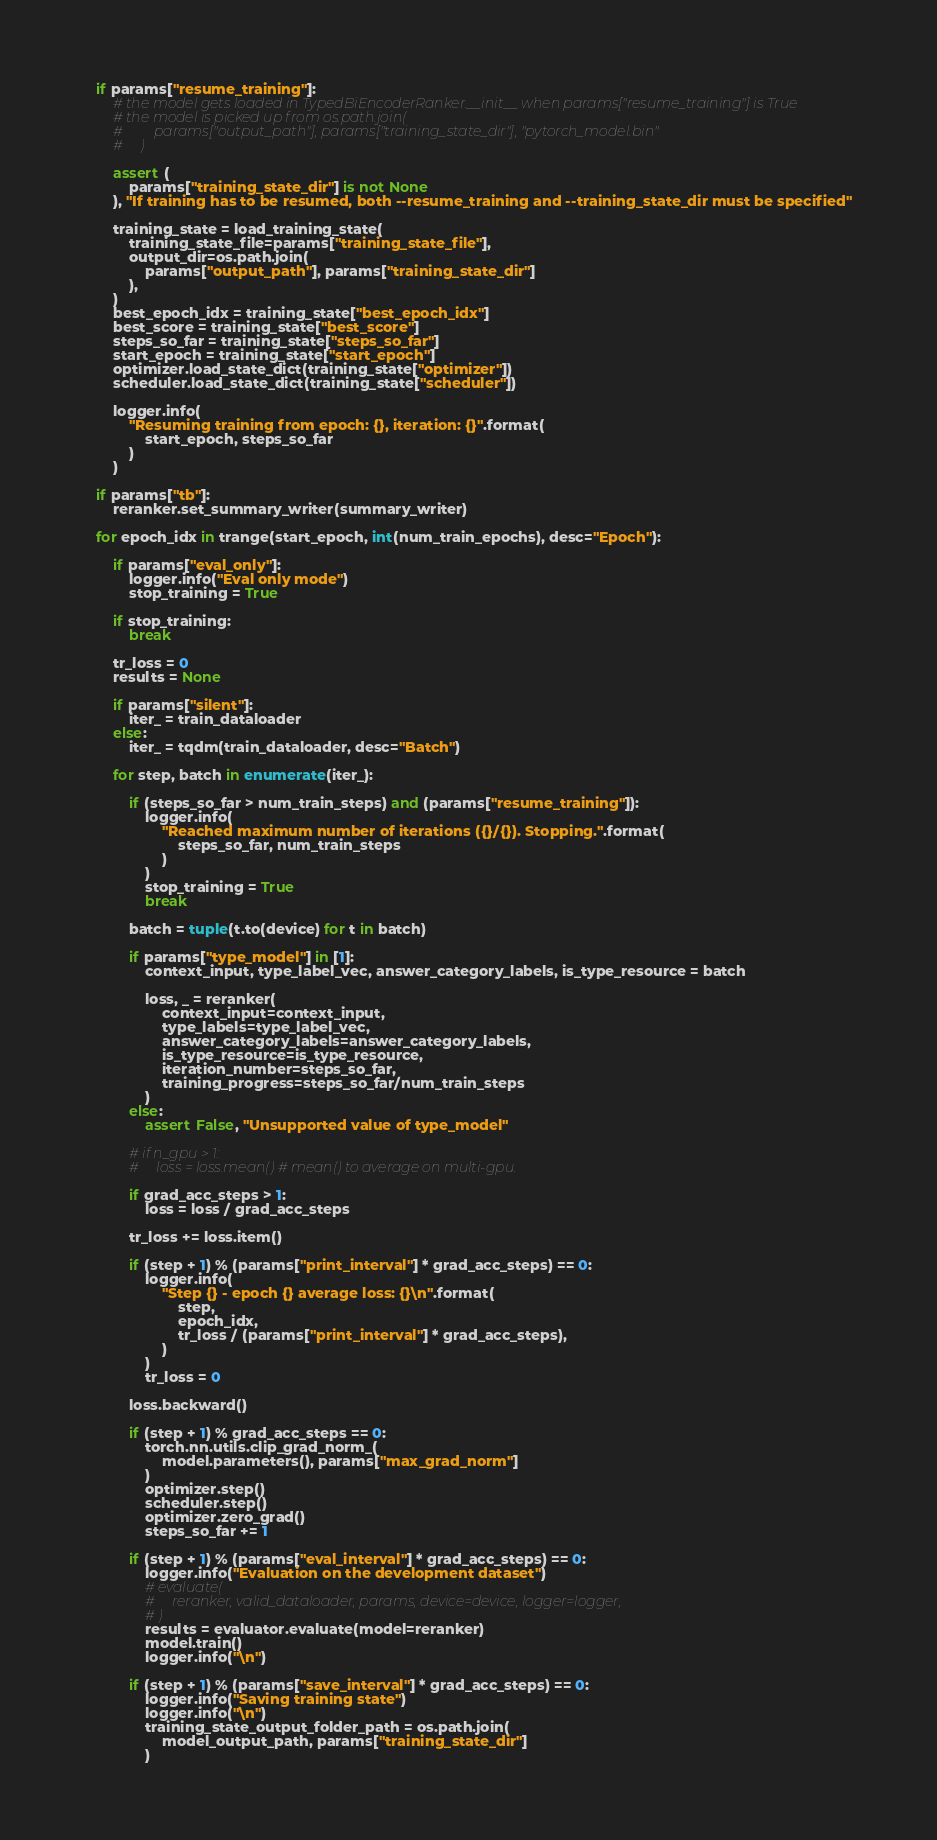<code> <loc_0><loc_0><loc_500><loc_500><_Python_>    if params["resume_training"]:
        # the model gets loaded in TypedBiEncoderRanker.__init__ when params["resume_training"] is True
        # the model is picked up from os.path.join(
        #         params["output_path"], params["training_state_dir"], "pytorch_model.bin"
        #     )

        assert (
            params["training_state_dir"] is not None
        ), "If training has to be resumed, both --resume_training and --training_state_dir must be specified"

        training_state = load_training_state(
            training_state_file=params["training_state_file"],
            output_dir=os.path.join(
                params["output_path"], params["training_state_dir"]
            ),
        )
        best_epoch_idx = training_state["best_epoch_idx"]
        best_score = training_state["best_score"]
        steps_so_far = training_state["steps_so_far"]
        start_epoch = training_state["start_epoch"]
        optimizer.load_state_dict(training_state["optimizer"])
        scheduler.load_state_dict(training_state["scheduler"])

        logger.info(
            "Resuming training from epoch: {}, iteration: {}".format(
                start_epoch, steps_so_far
            )
        )

    if params["tb"]:
        reranker.set_summary_writer(summary_writer)

    for epoch_idx in trange(start_epoch, int(num_train_epochs), desc="Epoch"):

        if params["eval_only"]:
            logger.info("Eval only mode")
            stop_training = True

        if stop_training:
            break

        tr_loss = 0
        results = None

        if params["silent"]:
            iter_ = train_dataloader
        else:
            iter_ = tqdm(train_dataloader, desc="Batch")

        for step, batch in enumerate(iter_):

            if (steps_so_far > num_train_steps) and (params["resume_training"]):
                logger.info(
                    "Reached maximum number of iterations ({}/{}). Stopping.".format(
                        steps_so_far, num_train_steps
                    )
                )
                stop_training = True
                break

            batch = tuple(t.to(device) for t in batch)

            if params["type_model"] in [1]:
                context_input, type_label_vec, answer_category_labels, is_type_resource = batch

                loss, _ = reranker(
                    context_input=context_input,
                    type_labels=type_label_vec,
                    answer_category_labels=answer_category_labels,
                    is_type_resource=is_type_resource,
                    iteration_number=steps_so_far,
                    training_progress=steps_so_far/num_train_steps
                )
            else:
                assert False, "Unsupported value of type_model"

            # if n_gpu > 1:
            #     loss = loss.mean() # mean() to average on multi-gpu.

            if grad_acc_steps > 1:
                loss = loss / grad_acc_steps

            tr_loss += loss.item()

            if (step + 1) % (params["print_interval"] * grad_acc_steps) == 0:
                logger.info(
                    "Step {} - epoch {} average loss: {}\n".format(
                        step,
                        epoch_idx,
                        tr_loss / (params["print_interval"] * grad_acc_steps),
                    )
                )
                tr_loss = 0

            loss.backward()

            if (step + 1) % grad_acc_steps == 0:
                torch.nn.utils.clip_grad_norm_(
                    model.parameters(), params["max_grad_norm"]
                )
                optimizer.step()
                scheduler.step()
                optimizer.zero_grad()
                steps_so_far += 1

            if (step + 1) % (params["eval_interval"] * grad_acc_steps) == 0:
                logger.info("Evaluation on the development dataset")
                # evaluate(
                #     reranker, valid_dataloader, params, device=device, logger=logger,
                # )
                results = evaluator.evaluate(model=reranker)
                model.train()
                logger.info("\n")

            if (step + 1) % (params["save_interval"] * grad_acc_steps) == 0:
                logger.info("Saving training state")
                logger.info("\n")
                training_state_output_folder_path = os.path.join(
                    model_output_path, params["training_state_dir"]
                )</code> 